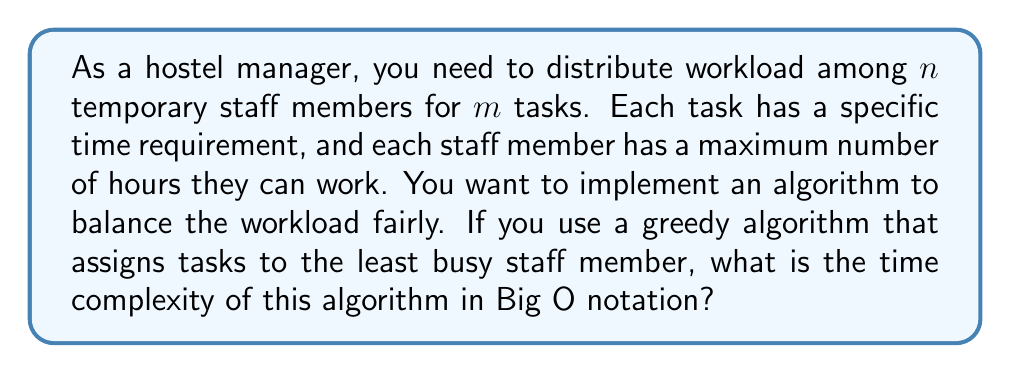What is the answer to this math problem? To analyze the time complexity of this greedy algorithm, let's break it down step by step:

1. For each task (total $m$ tasks):
   a. We need to find the least busy staff member among $n$ staff.
   b. Assign the task to that staff member.

2. Finding the least busy staff member:
   - This requires comparing the current workload of all $n$ staff members.
   - Time complexity: $O(n)$

3. Assigning the task:
   - This is a constant time operation.
   - Time complexity: $O(1)$

4. We repeat steps 2 and 3 for each of the $m$ tasks.

Therefore, the total time complexity is:

$$O(m \cdot (n + 1)) = O(mn + m)$$

Since $m$ is typically much smaller than $mn$, we can simplify this to:

$$O(mn)$$

This algorithm has a quadratic time complexity with respect to the number of staff members when the number of tasks is similar to or greater than the number of staff. It's linear with respect to the number of tasks.

Note: This greedy approach doesn't guarantee an optimal solution but provides a reasonably fair distribution in most cases, which is often sufficient for temporary staff management in a hostel setting.
Answer: $O(mn)$ 